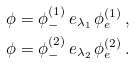Convert formula to latex. <formula><loc_0><loc_0><loc_500><loc_500>\phi & = \phi _ { - } ^ { ( 1 ) } \, e _ { \lambda _ { 1 } } \, \phi _ { e } ^ { ( 1 ) } \, , \\ \phi & = \phi _ { - } ^ { ( 2 ) } \, e _ { \lambda _ { 2 } } \, \phi _ { e } ^ { ( 2 ) } \, .</formula> 